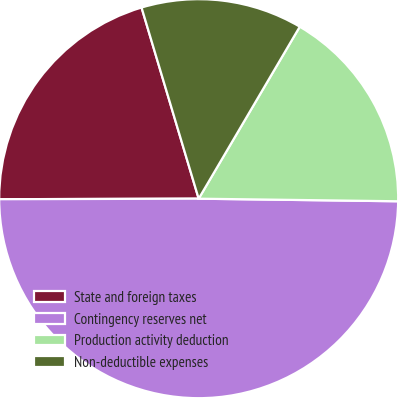Convert chart. <chart><loc_0><loc_0><loc_500><loc_500><pie_chart><fcel>State and foreign taxes<fcel>Contingency reserves net<fcel>Production activity deduction<fcel>Non-deductible expenses<nl><fcel>20.42%<fcel>49.75%<fcel>16.75%<fcel>13.08%<nl></chart> 